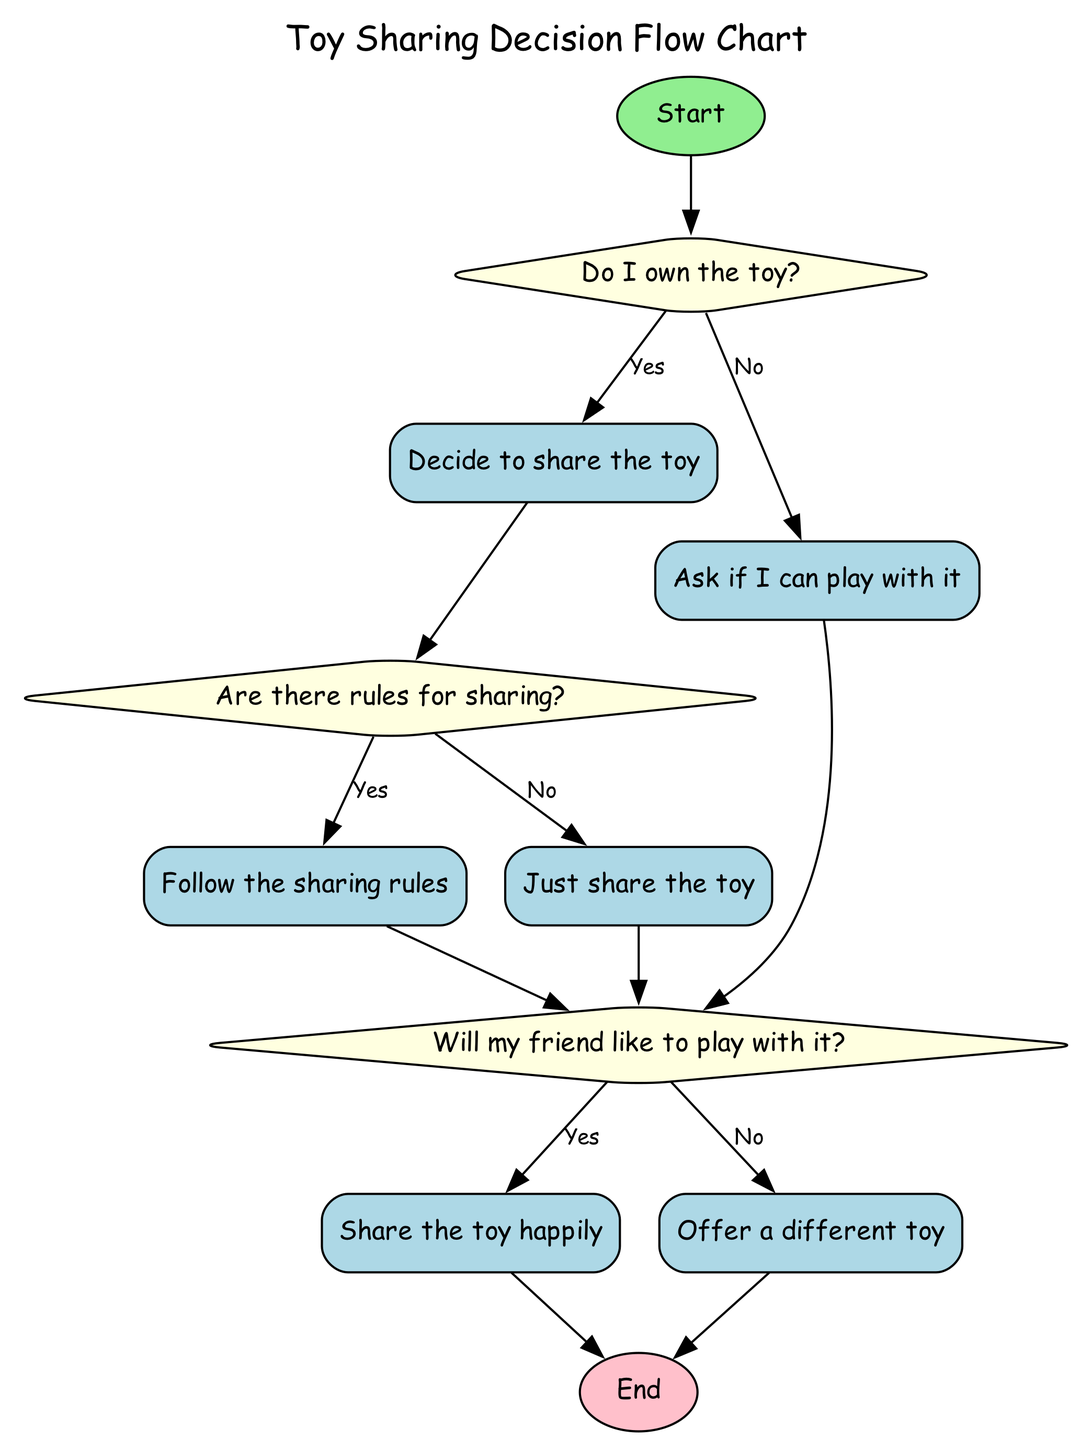What is the first action in this flow chart? The first action flows from the start node to "CheckToyOwnership," which is the decision point to determine if the toy is owned.
Answer: CheckToyOwnership How many decision points are in the flow chart? There are four decision points: "CheckToyOwnership," "CheckSharingRules," and "CheckFriendFeelings."
Answer: Four What happens if I own the toy and there are no sharing rules? If I own the toy and there are no sharing rules, the flow proceeds from "NoRules" to "CheckFriendFeelings," meaning the next step is to evaluate my friend's willingness to play with it.
Answer: CheckFriendFeelings What action follows if my friend does not like to play with the toy? If my friend does not like to play with the toy, the flow continues from "NoFriendDoesNot" to the end of the process, indicating that the decision-making for sharing that toy concludes there.
Answer: End What is the label of the node that follows after deciding to share the toy? After deciding to share the toy, the next step is to check if there are rules for sharing, which is represented by the "CheckSharingRules" decision point.
Answer: CheckSharingRules What action occurs if the toy is not owned? If the toy is not owned, the flow leads directly to "Ask if I can play with it," representing the action taken when the toy does not belong to me.
Answer: Ask if I can play with it Which action leads to the end of the flow chart if the friend likes to play with the toy? If the friend likes to play with the toy, the flow proceeds directly to "YesFriendLikes," after which it ends the decision-making process.
Answer: End 